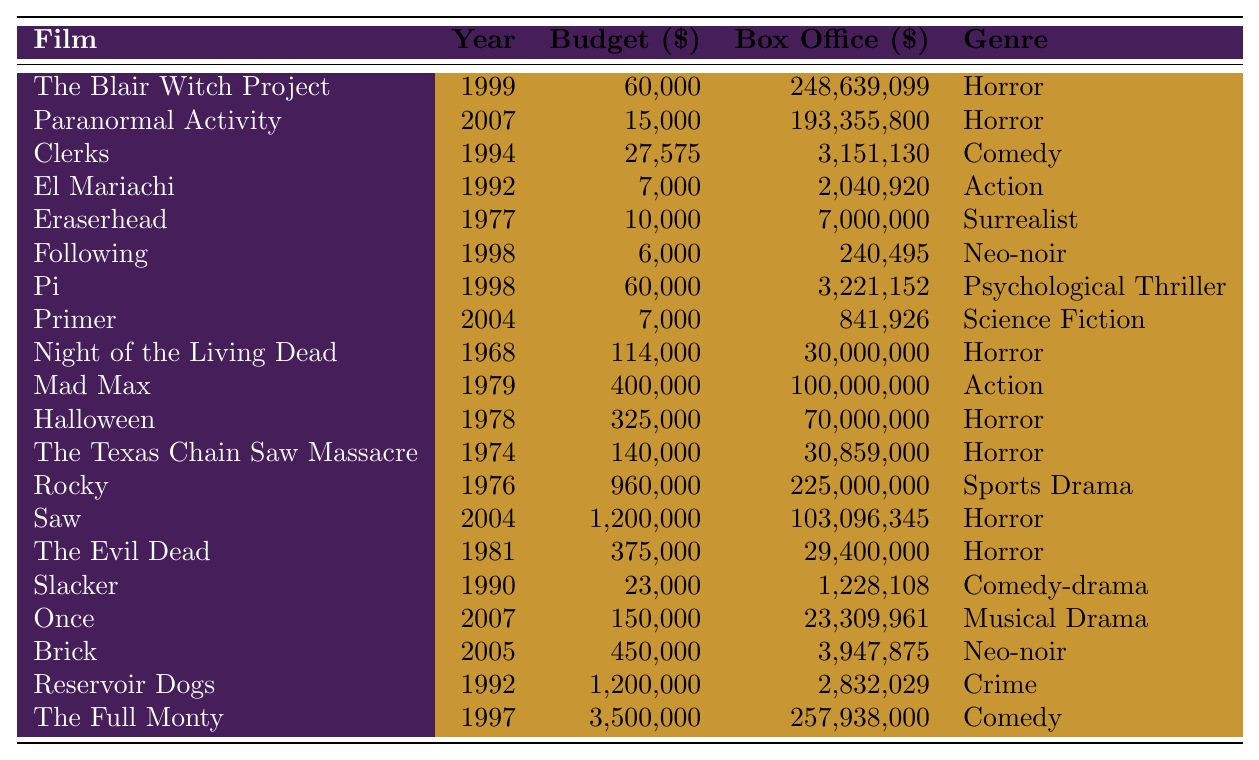What is the budget of "The Blair Witch Project"? The budget for "The Blair Witch Project" is listed in the table, and it is $60,000.
Answer: $60,000 Which film had the highest box office gross? By scanning through the box office values in the table, "The Blair Witch Project" had the highest box office gross at $248,639,099.
Answer: "The Blair Witch Project" What is the genre of "Prim"? The genre of "Primer" is provided in the table, which lists it as "Science Fiction."
Answer: Science Fiction How much was the budget of the lowest-budget film? "Following" has the lowest budget in the table at $6,000.
Answer: $6,000 What is the difference between the highest and the lowest box office returns? The highest box office is from "The Blair Witch Project" at $248,639,099 and the lowest is from "Following" at $240,495. The difference is $248,639,099 - $240,495 = $248,398,604.
Answer: $248,398,604 Which genre had the most films listed? By reviewing the genres in the table, the "Horror" genre appears the most frequently, with 7 entries.
Answer: Horror What was the combined budget of all films in the list? To find the combined budget, we sum the individual budgets listed in the table: $60,000 + $15,000 + $27,575 + $7,000 + $10,000 + $6,000 + $60,000 + $7,000 + $114,000 + $400,000 + $325,000 + $140,000 + $960,000 + $1,200,000 + $375,000 + $23,000 + $150,000 + $450,000 + $1,200,000 + $3,500,000 = $8,454,575.
Answer: $8,454,575 Is "Reservoir Dogs" a Comedy? Looking at the genre listed for "Reservoir Dogs," it is classified as "Crime," not a comedy.
Answer: No What percentage of films had a box office return greater than $10 million? By counting the films with a box office greater than $10 million (which includes 11 films) and dividing by the total number of films (20) gives us 11/20 = 0.55 or 55%.
Answer: 55% What is the average budget of the horror films listed? We sum the budgets of the horror films ($60,000 + $15,000 + $114,000 + $140,000 + $325,000 + $960,000 + $1,200,000) which totals $2,814,000. There are 7 horror films, so the average budget is $2,814,000 / 7 = $402,000.
Answer: $402,000 Which film had the highest budget in the table? The film with the highest budget is "The Full Monty" at $3,500,000 as seen in the table.
Answer: "The Full Monty" 